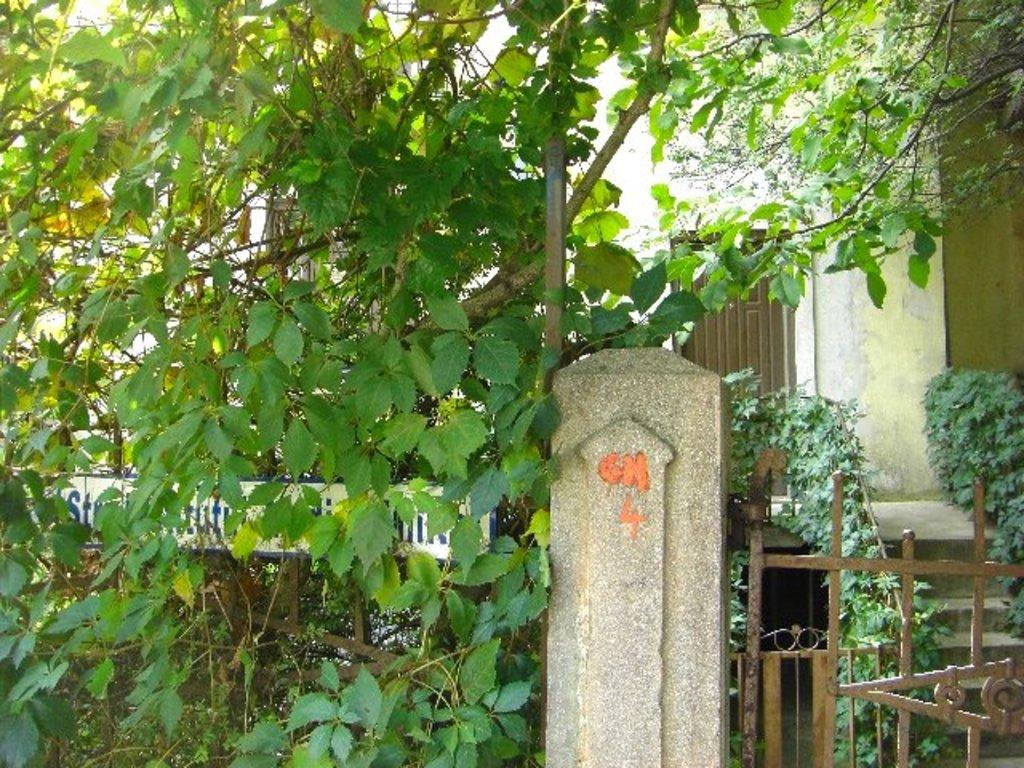What type of structure can be seen in the image? There is a gate in the image. What natural element is present in the image? There is a tree in the image. What are the gate railings made of? The gate railings are visible in the image. Are there any architectural features in the image? Yes, there are steps and a wall in the image. What is another entrance feature present in the image? There is a door in the image. How many ladybugs are crawling on the tree in the image? There are no ladybugs present in the image; it only features a tree, gate, railings, steps, wall, and door. What answer is written on the wall in the image? There is no text or answer written on the wall in the image. 